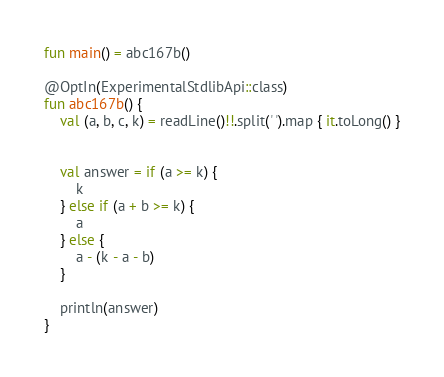Convert code to text. <code><loc_0><loc_0><loc_500><loc_500><_Kotlin_>fun main() = abc167b()

@OptIn(ExperimentalStdlibApi::class)
fun abc167b() {
    val (a, b, c, k) = readLine()!!.split(' ').map { it.toLong() }


    val answer = if (a >= k) {
        k
    } else if (a + b >= k) {
        a
    } else {
        a - (k - a - b)
    }

    println(answer)
}
</code> 